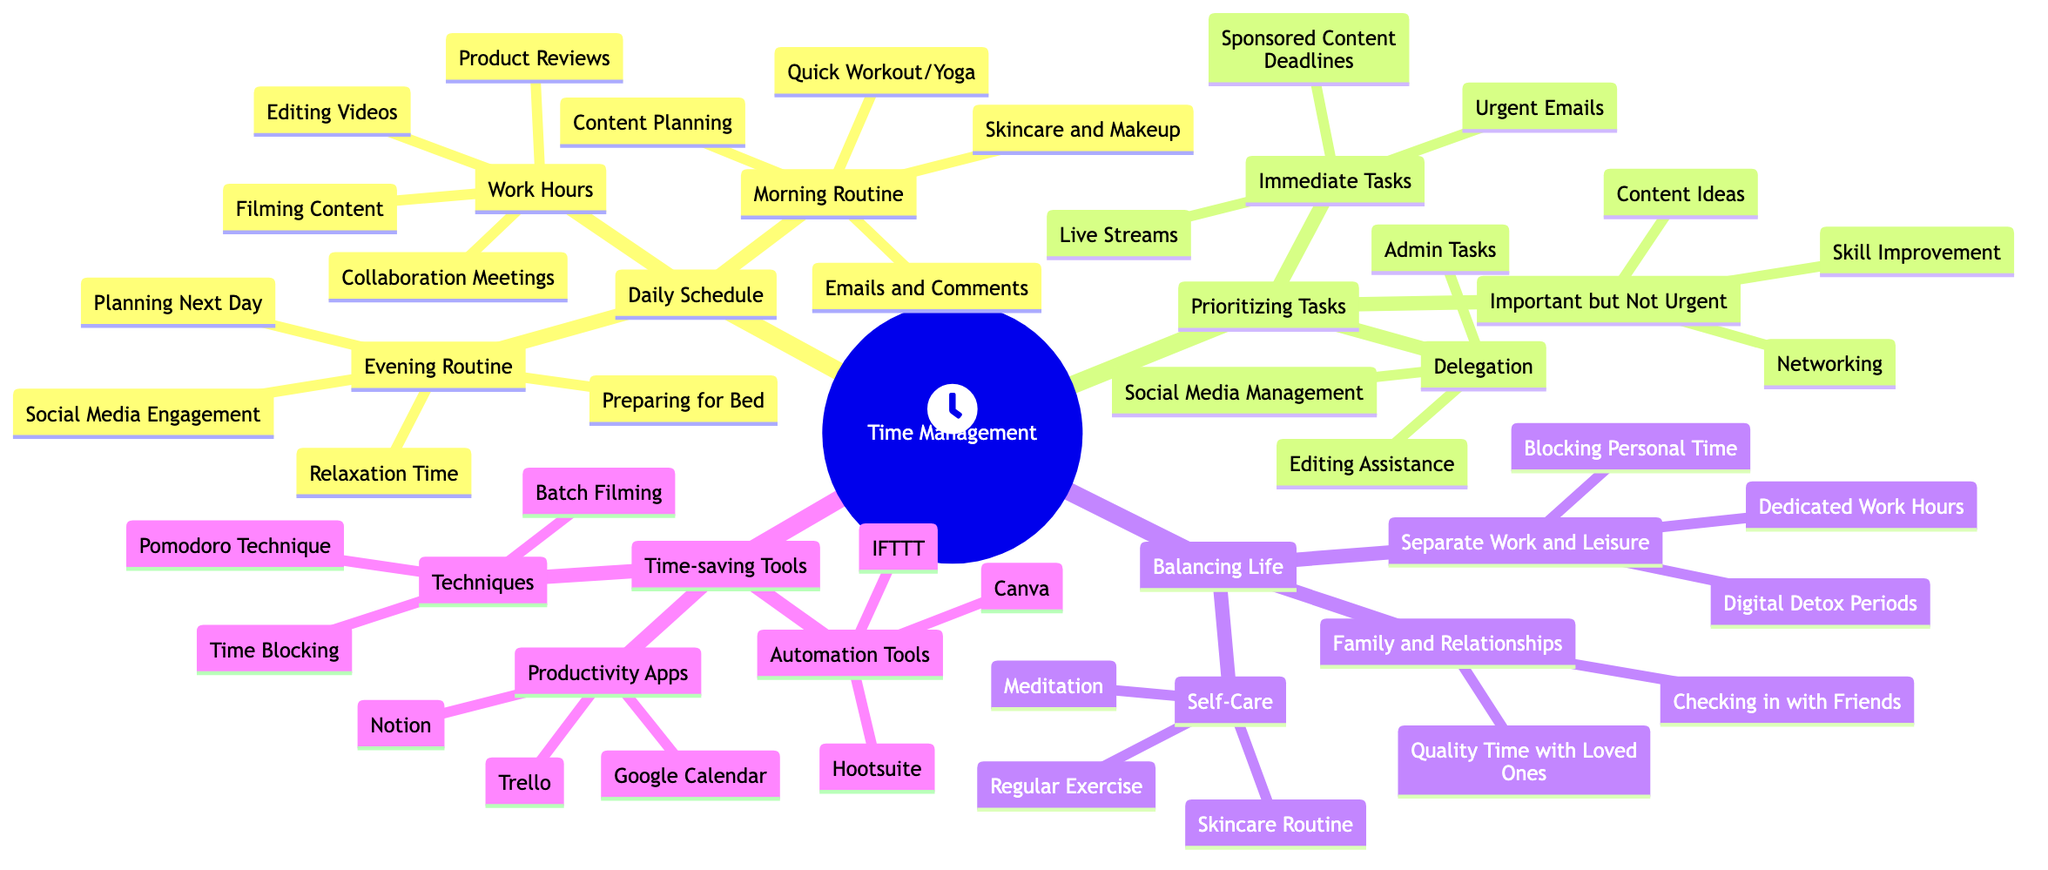What are the components of the morning routine? The morning routine breaks down into four specific tasks: skincare and makeup, content planning, answering emails and comments, and a quick workout or yoga.
Answer: skincare and makeup, content planning, answering emails and comments, quick workout/yoga How many categories are in "Prioritizing Tasks"? The "Prioritizing Tasks" section has three distinct categories: immediate tasks, important but not urgent, and delegation.
Answer: 3 What technique is included for improving productivity? One of the techniques mentioned for improving productivity is the Pomodoro Technique, which is designed to enhance focus and time management.
Answer: Pomodoro Technique What is one example of an automation tool? Hootsuite is listed as an automation tool for scheduling social media posts efficiently, providing a way to manage online presence effectively.
Answer: Hootsuite Which routine includes social media engagement? The evening routine specifically lists social media engagement as one of its key activities, aiming to maintain and grow online interaction.
Answer: Evening Routine What does "Blocking Personal Time" refer to in the context of balancing life? "Blocking Personal Time" refers to intentionally scheduling time away from work duties to ensure a healthy work-life balance and prioritizing personal commitments.
Answer: Blocking Personal Time Which task is considered "Important but Not Urgent"? Content ideas fall under the category of "Important but Not Urgent," highlighting the significance of brainstorming and planning for future content amidst urgent tasks.
Answer: Content Ideas How many tasks are listed under immediate tasks? There are three specific tasks listed under immediate tasks: sponsored content deadlines, live streams, and urgent emails, emphasizing the need to address these promptly.
Answer: 3 What does "Batch Filming" aim to achieve? Batch filming is a technique aimed at increasing efficiency by filming multiple pieces of content in one session, saving time and effort on setting up.
Answer: Batch Filming 